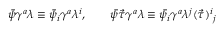<formula> <loc_0><loc_0><loc_500><loc_500>\bar { \psi } \gamma ^ { a } \lambda \equiv \bar { \psi } _ { i } \gamma ^ { a } \lambda ^ { i } , \quad \bar { \psi } \vec { \tau } \gamma ^ { a } \lambda \equiv \bar { \psi } _ { i } \gamma ^ { a } \lambda ^ { j } ( \vec { \tau } ) ^ { i _ { j }</formula> 